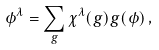<formula> <loc_0><loc_0><loc_500><loc_500>\phi ^ { \lambda } = \sum _ { g } \chi ^ { \lambda } ( g ) g ( \phi ) \, ,</formula> 